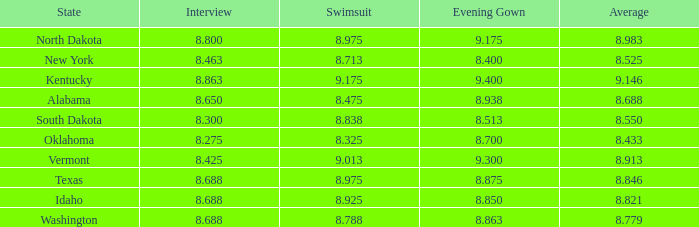425? None. Can you parse all the data within this table? {'header': ['State', 'Interview', 'Swimsuit', 'Evening Gown', 'Average'], 'rows': [['North Dakota', '8.800', '8.975', '9.175', '8.983'], ['New York', '8.463', '8.713', '8.400', '8.525'], ['Kentucky', '8.863', '9.175', '9.400', '9.146'], ['Alabama', '8.650', '8.475', '8.938', '8.688'], ['South Dakota', '8.300', '8.838', '8.513', '8.550'], ['Oklahoma', '8.275', '8.325', '8.700', '8.433'], ['Vermont', '8.425', '9.013', '9.300', '8.913'], ['Texas', '8.688', '8.975', '8.875', '8.846'], ['Idaho', '8.688', '8.925', '8.850', '8.821'], ['Washington', '8.688', '8.788', '8.863', '8.779']]} 